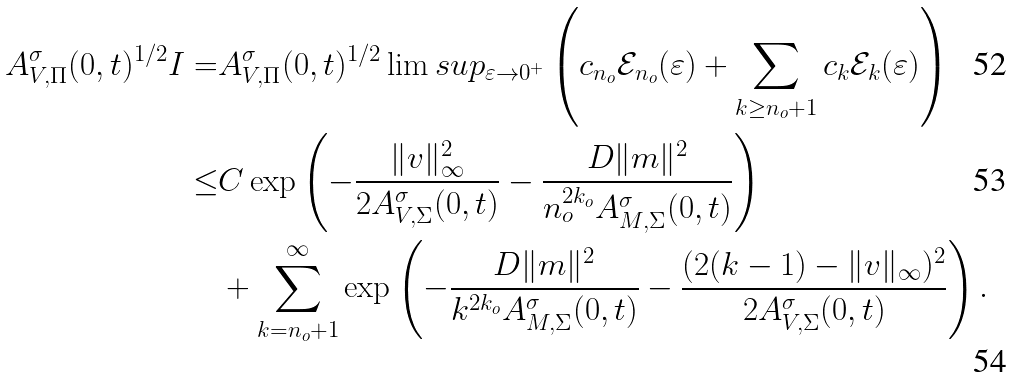Convert formula to latex. <formula><loc_0><loc_0><loc_500><loc_500>A _ { V , \Pi } ^ { \sigma } ( 0 , t ) ^ { 1 \slash 2 } I = & A _ { V , \Pi } ^ { \sigma } ( 0 , t ) ^ { 1 \slash 2 } \lim s u p _ { \varepsilon \to 0 ^ { + } } \left ( c _ { n _ { o } } \mathcal { E } _ { n _ { o } } ( \varepsilon ) + \sum _ { k \geq n _ { o } + 1 } c _ { k } \mathcal { E } _ { k } ( \varepsilon ) \right ) \\ \leq & C \exp \left ( - \frac { \| v \| _ { \infty } ^ { 2 } } { 2 A _ { V , \Sigma } ^ { \sigma } ( 0 , t ) } - \frac { D \| m \| ^ { 2 } } { n _ { o } ^ { 2 k _ { o } } A _ { M , \Sigma } ^ { \sigma } ( 0 , t ) } \right ) \\ & + \sum _ { k = n _ { o } + 1 } ^ { \infty } \exp \left ( - \frac { D \| m \| ^ { 2 } } { k ^ { 2 k _ { o } } A _ { M , \Sigma } ^ { \sigma } ( 0 , t ) } - \frac { ( 2 ( k - 1 ) - \| v \| _ { \infty } ) ^ { 2 } } { 2 A _ { V , \Sigma } ^ { \sigma } ( 0 , t ) } \right ) .</formula> 